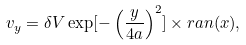Convert formula to latex. <formula><loc_0><loc_0><loc_500><loc_500>v _ { y } = \delta V \exp [ - \left ( \frac { y } { 4 a } \right ) ^ { 2 } ] \times r a n ( x ) ,</formula> 